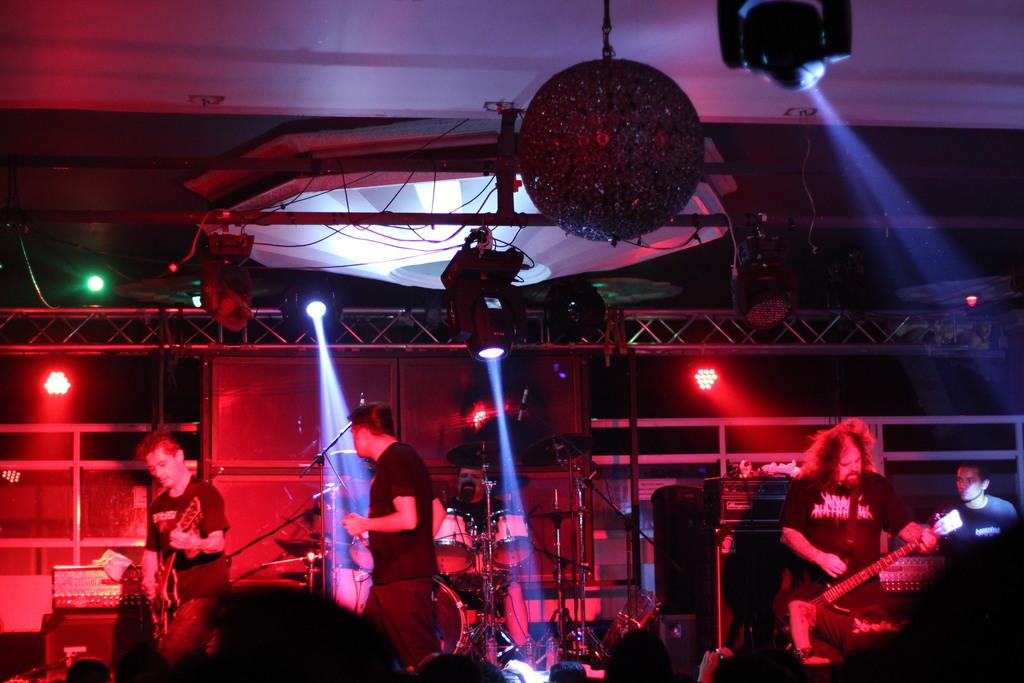What type of people are present in the image? There are musicians in the image. Can you describe the actions of the musicians in the image? A man in the left corner is playing a guitar, and a man in the right corner is also playing a guitar. What other instruments can be seen in the image? There are drums and drum stands in the image. What equipment is used for amplifying sound in the image? There are microphones in the image. What type of lighting is present in the image? There are spotlights in the image. What is the purpose of the tax in the image? There is no mention of tax in the image; it features musicians and their instruments. What type of book is the musician reading in the image? There is no book or reading activity depicted in the image; the musicians are playing their instruments. 